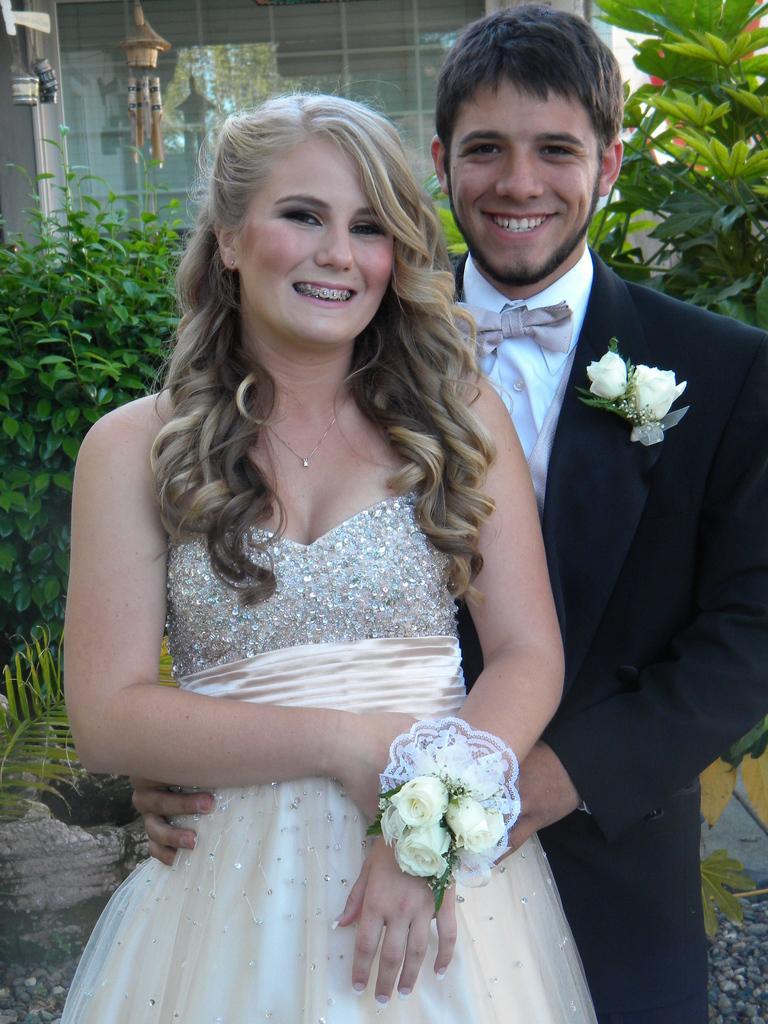Please provide a concise description of this image. In the center of the image we can see a lady we can see a lady and a man standing and smiling. In the background there are trees. On the left there are wind chimes. In the background there is a building. 